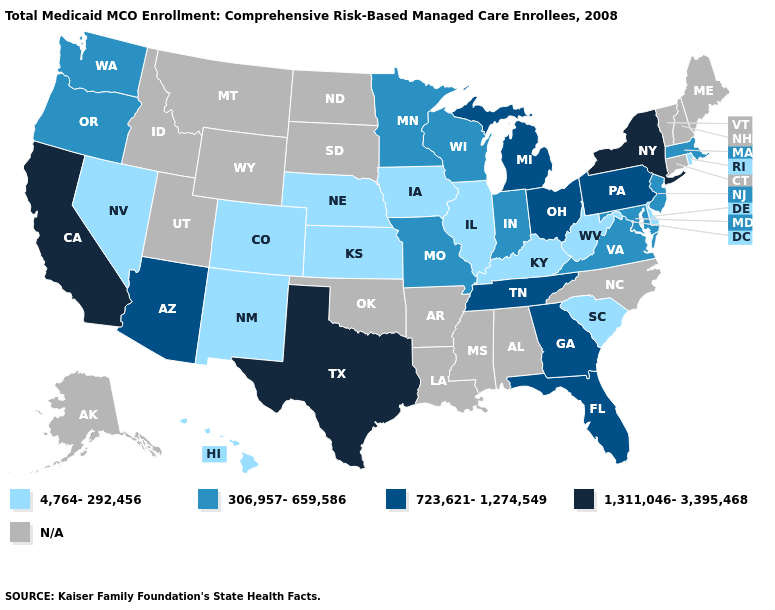What is the value of Wyoming?
Quick response, please. N/A. What is the lowest value in states that border Vermont?
Be succinct. 306,957-659,586. Name the states that have a value in the range N/A?
Answer briefly. Alabama, Alaska, Arkansas, Connecticut, Idaho, Louisiana, Maine, Mississippi, Montana, New Hampshire, North Carolina, North Dakota, Oklahoma, South Dakota, Utah, Vermont, Wyoming. What is the value of Michigan?
Be succinct. 723,621-1,274,549. What is the value of Pennsylvania?
Keep it brief. 723,621-1,274,549. Name the states that have a value in the range 306,957-659,586?
Answer briefly. Indiana, Maryland, Massachusetts, Minnesota, Missouri, New Jersey, Oregon, Virginia, Washington, Wisconsin. Name the states that have a value in the range 4,764-292,456?
Concise answer only. Colorado, Delaware, Hawaii, Illinois, Iowa, Kansas, Kentucky, Nebraska, Nevada, New Mexico, Rhode Island, South Carolina, West Virginia. How many symbols are there in the legend?
Write a very short answer. 5. Does Hawaii have the lowest value in the USA?
Keep it brief. Yes. Which states have the highest value in the USA?
Give a very brief answer. California, New York, Texas. Does Pennsylvania have the lowest value in the USA?
Keep it brief. No. Name the states that have a value in the range N/A?
Give a very brief answer. Alabama, Alaska, Arkansas, Connecticut, Idaho, Louisiana, Maine, Mississippi, Montana, New Hampshire, North Carolina, North Dakota, Oklahoma, South Dakota, Utah, Vermont, Wyoming. 